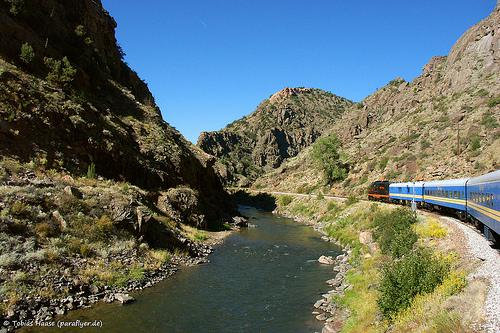Question: where is the train?
Choices:
A. On the train tracks.
B. In the mountains.
C. On the bridge.
D. In the tunnel.
Answer with the letter. Answer: B Question: how many mountains are visible?
Choices:
A. One.
B. Two.
C. Four.
D. Three.
Answer with the letter. Answer: D Question: how many train cars are visible?
Choices:
A. Three.
B. One.
C. Two.
D. Four.
Answer with the letter. Answer: A Question: what color are the train cars?
Choices:
A. Green purple and blue.
B. Pink red and orange.
C. Blue white and yellow.
D. Silver green and brown.
Answer with the letter. Answer: C 